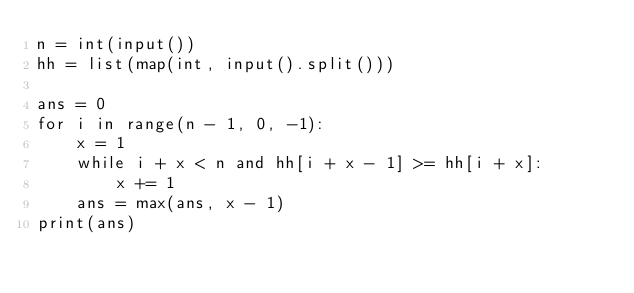Convert code to text. <code><loc_0><loc_0><loc_500><loc_500><_Python_>n = int(input())
hh = list(map(int, input().split()))

ans = 0
for i in range(n - 1, 0, -1):
    x = 1
    while i + x < n and hh[i + x - 1] >= hh[i + x]:
        x += 1
    ans = max(ans, x - 1)
print(ans)
</code> 